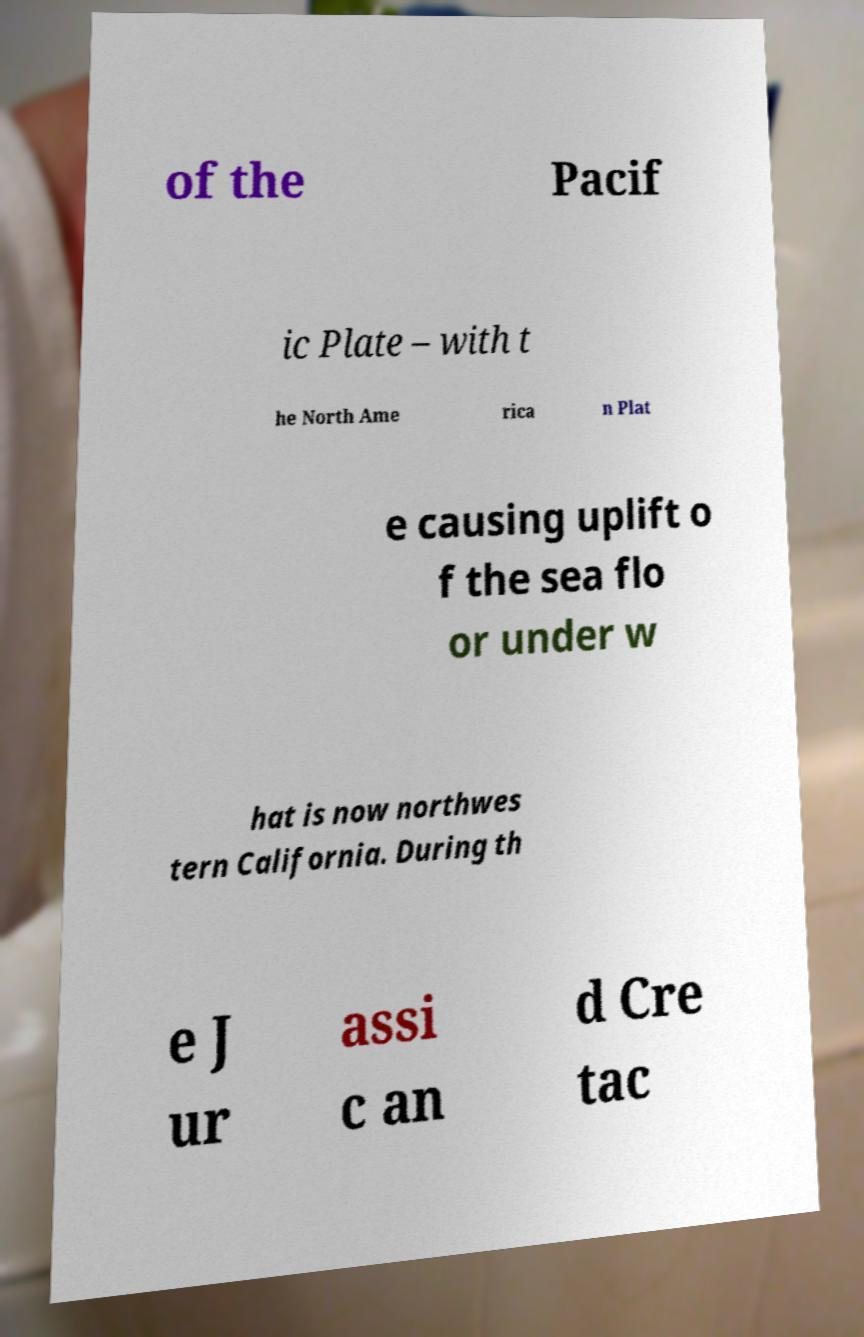There's text embedded in this image that I need extracted. Can you transcribe it verbatim? of the Pacif ic Plate – with t he North Ame rica n Plat e causing uplift o f the sea flo or under w hat is now northwes tern California. During th e J ur assi c an d Cre tac 